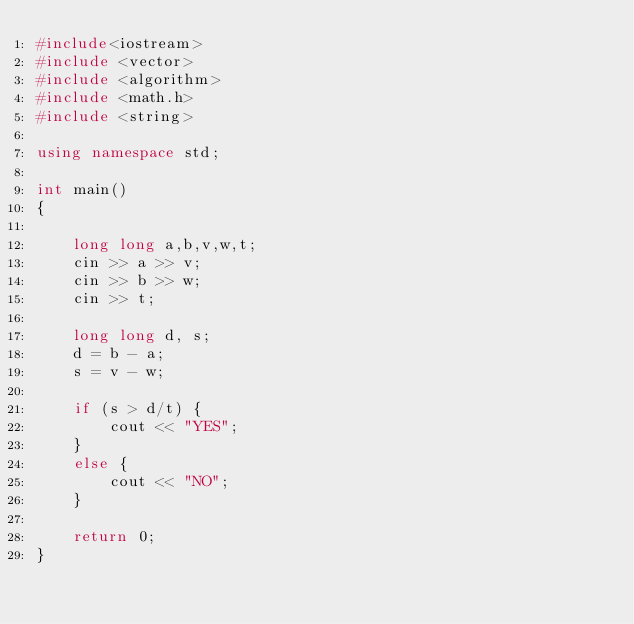<code> <loc_0><loc_0><loc_500><loc_500><_C++_>#include<iostream>
#include <vector>
#include <algorithm>
#include <math.h>
#include <string>

using namespace std;

int main()
{

    long long a,b,v,w,t;
    cin >> a >> v;
    cin >> b >> w;
    cin >> t;

    long long d, s;
    d = b - a;
    s = v - w;

    if (s > d/t) {
        cout << "YES";
    }
    else {
        cout << "NO";
    }

    return 0;
}</code> 